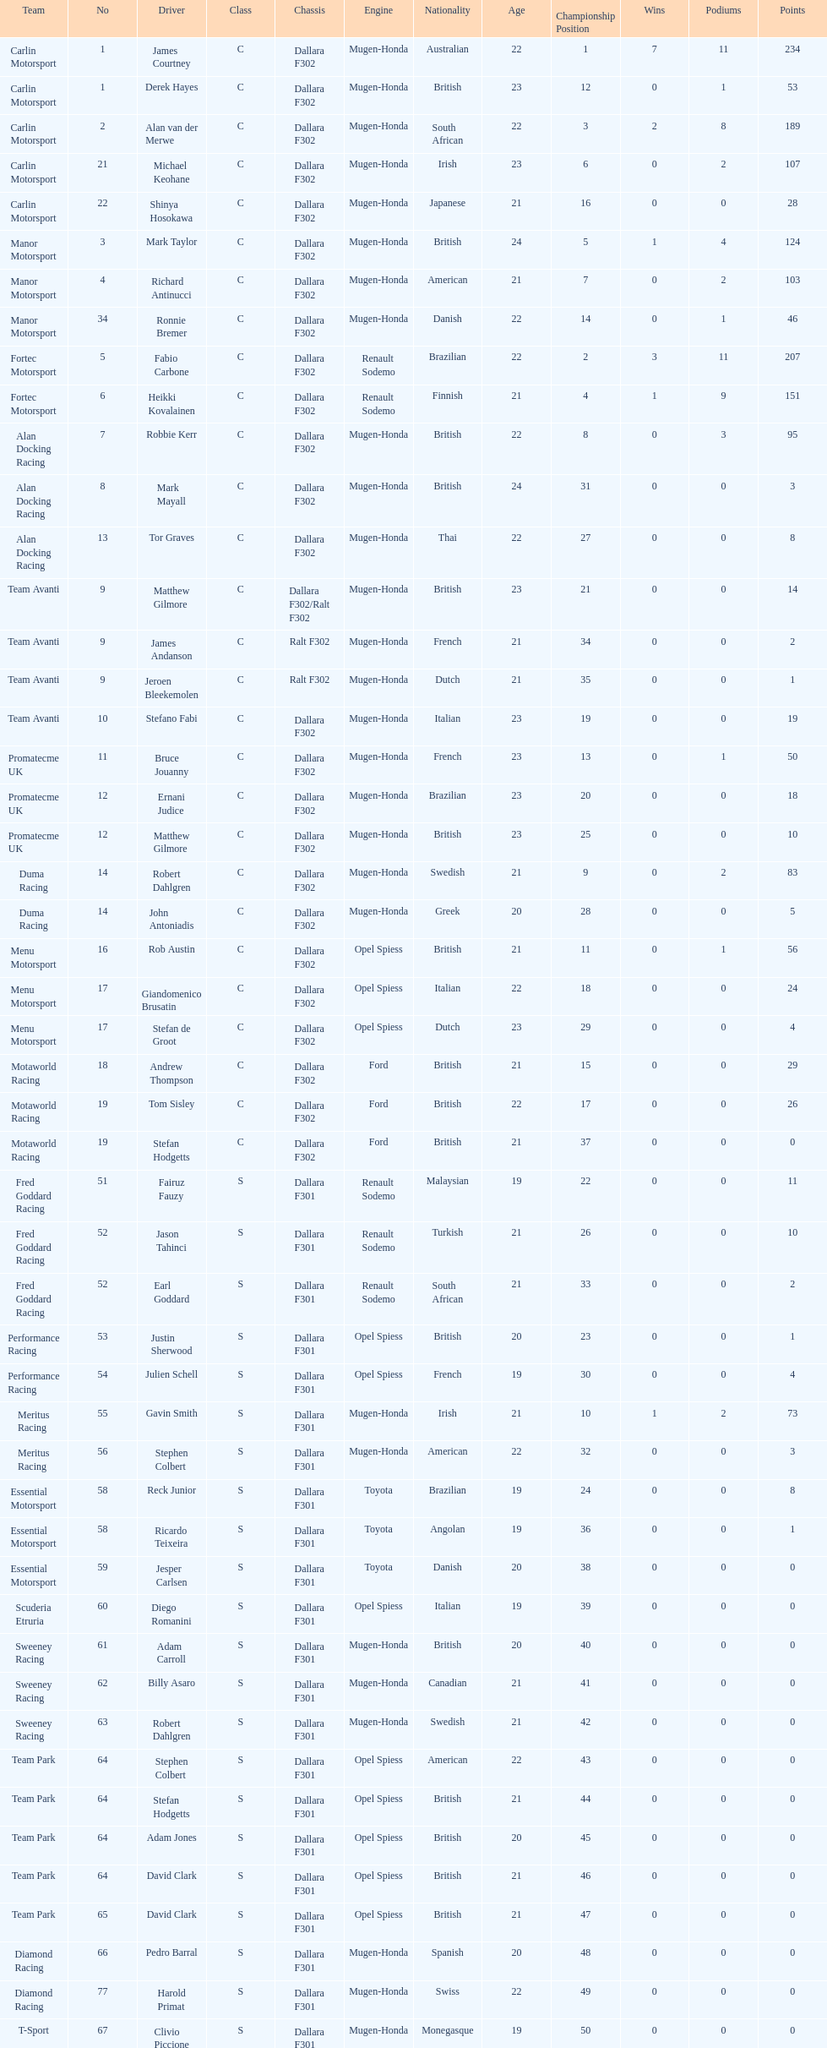Can you give me this table as a dict? {'header': ['Team', 'No', 'Driver', 'Class', 'Chassis', 'Engine', 'Nationality', 'Age', 'Championship Position', 'Wins', 'Podiums', 'Points'], 'rows': [['Carlin Motorsport', '1', 'James Courtney', 'C', 'Dallara F302', 'Mugen-Honda', 'Australian', '22', '1', '7', '11', '234'], ['Carlin Motorsport', '1', 'Derek Hayes', 'C', 'Dallara F302', 'Mugen-Honda', 'British', '23', '12', '0', '1', '53'], ['Carlin Motorsport', '2', 'Alan van der Merwe', 'C', 'Dallara F302', 'Mugen-Honda', 'South African', '22', '3', '2', '8', '189'], ['Carlin Motorsport', '21', 'Michael Keohane', 'C', 'Dallara F302', 'Mugen-Honda', 'Irish', '23', '6', '0', '2', '107'], ['Carlin Motorsport', '22', 'Shinya Hosokawa', 'C', 'Dallara F302', 'Mugen-Honda', 'Japanese', '21', '16', '0', '0', '28'], ['Manor Motorsport', '3', 'Mark Taylor', 'C', 'Dallara F302', 'Mugen-Honda', 'British', '24', '5', '1', '4', '124'], ['Manor Motorsport', '4', 'Richard Antinucci', 'C', 'Dallara F302', 'Mugen-Honda', 'American', '21', '7', '0', '2', '103'], ['Manor Motorsport', '34', 'Ronnie Bremer', 'C', 'Dallara F302', 'Mugen-Honda', 'Danish', '22', '14', '0', '1', '46'], ['Fortec Motorsport', '5', 'Fabio Carbone', 'C', 'Dallara F302', 'Renault Sodemo', 'Brazilian', '22', '2', '3', '11', '207'], ['Fortec Motorsport', '6', 'Heikki Kovalainen', 'C', 'Dallara F302', 'Renault Sodemo', 'Finnish', '21', '4', '1', '9', '151'], ['Alan Docking Racing', '7', 'Robbie Kerr', 'C', 'Dallara F302', 'Mugen-Honda', 'British', '22', '8', '0', '3', '95'], ['Alan Docking Racing', '8', 'Mark Mayall', 'C', 'Dallara F302', 'Mugen-Honda', 'British', '24', '31', '0', '0', '3'], ['Alan Docking Racing', '13', 'Tor Graves', 'C', 'Dallara F302', 'Mugen-Honda', 'Thai', '22', '27', '0', '0', '8'], ['Team Avanti', '9', 'Matthew Gilmore', 'C', 'Dallara F302/Ralt F302', 'Mugen-Honda', 'British', '23', '21', '0', '0', '14'], ['Team Avanti', '9', 'James Andanson', 'C', 'Ralt F302', 'Mugen-Honda', 'French', '21', '34', '0', '0', '2'], ['Team Avanti', '9', 'Jeroen Bleekemolen', 'C', 'Ralt F302', 'Mugen-Honda', 'Dutch', '21', '35', '0', '0', '1'], ['Team Avanti', '10', 'Stefano Fabi', 'C', 'Dallara F302', 'Mugen-Honda', 'Italian', '23', '19', '0', '0', '19'], ['Promatecme UK', '11', 'Bruce Jouanny', 'C', 'Dallara F302', 'Mugen-Honda', 'French', '23', '13', '0', '1', '50'], ['Promatecme UK', '12', 'Ernani Judice', 'C', 'Dallara F302', 'Mugen-Honda', 'Brazilian', '23', '20', '0', '0', '18'], ['Promatecme UK', '12', 'Matthew Gilmore', 'C', 'Dallara F302', 'Mugen-Honda', 'British', '23', '25', '0', '0', '10'], ['Duma Racing', '14', 'Robert Dahlgren', 'C', 'Dallara F302', 'Mugen-Honda', 'Swedish', '21', '9', '0', '2', '83'], ['Duma Racing', '14', 'John Antoniadis', 'C', 'Dallara F302', 'Mugen-Honda', 'Greek', '20', '28', '0', '0', '5'], ['Menu Motorsport', '16', 'Rob Austin', 'C', 'Dallara F302', 'Opel Spiess', 'British', '21', '11', '0', '1', '56'], ['Menu Motorsport', '17', 'Giandomenico Brusatin', 'C', 'Dallara F302', 'Opel Spiess', 'Italian', '22', '18', '0', '0', '24'], ['Menu Motorsport', '17', 'Stefan de Groot', 'C', 'Dallara F302', 'Opel Spiess', 'Dutch', '23', '29', '0', '0', '4'], ['Motaworld Racing', '18', 'Andrew Thompson', 'C', 'Dallara F302', 'Ford', 'British', '21', '15', '0', '0', '29'], ['Motaworld Racing', '19', 'Tom Sisley', 'C', 'Dallara F302', 'Ford', 'British', '22', '17', '0', '0', '26'], ['Motaworld Racing', '19', 'Stefan Hodgetts', 'C', 'Dallara F302', 'Ford', 'British', '21', '37', '0', '0', '0'], ['Fred Goddard Racing', '51', 'Fairuz Fauzy', 'S', 'Dallara F301', 'Renault Sodemo', 'Malaysian', '19', '22', '0', '0', '11'], ['Fred Goddard Racing', '52', 'Jason Tahinci', 'S', 'Dallara F301', 'Renault Sodemo', 'Turkish', '21', '26', '0', '0', '10'], ['Fred Goddard Racing', '52', 'Earl Goddard', 'S', 'Dallara F301', 'Renault Sodemo', 'South African', '21', '33', '0', '0', '2'], ['Performance Racing', '53', 'Justin Sherwood', 'S', 'Dallara F301', 'Opel Spiess', 'British', '20', '23', '0', '0', '1'], ['Performance Racing', '54', 'Julien Schell', 'S', 'Dallara F301', 'Opel Spiess', 'French', '19', '30', '0', '0', '4'], ['Meritus Racing', '55', 'Gavin Smith', 'S', 'Dallara F301', 'Mugen-Honda', 'Irish', '21', '10', '1', '2', '73'], ['Meritus Racing', '56', 'Stephen Colbert', 'S', 'Dallara F301', 'Mugen-Honda', 'American', '22', '32', '0', '0', '3'], ['Essential Motorsport', '58', 'Reck Junior', 'S', 'Dallara F301', 'Toyota', 'Brazilian', '19', '24', '0', '0', '8'], ['Essential Motorsport', '58', 'Ricardo Teixeira', 'S', 'Dallara F301', 'Toyota', 'Angolan', '19', '36', '0', '0', '1'], ['Essential Motorsport', '59', 'Jesper Carlsen', 'S', 'Dallara F301', 'Toyota', 'Danish', '20', '38', '0', '0', '0'], ['Scuderia Etruria', '60', 'Diego Romanini', 'S', 'Dallara F301', 'Opel Spiess', 'Italian', '19', '39', '0', '0', '0'], ['Sweeney Racing', '61', 'Adam Carroll', 'S', 'Dallara F301', 'Mugen-Honda', 'British', '20', '40', '0', '0', '0'], ['Sweeney Racing', '62', 'Billy Asaro', 'S', 'Dallara F301', 'Mugen-Honda', 'Canadian', '21', '41', '0', '0', '0'], ['Sweeney Racing', '63', 'Robert Dahlgren', 'S', 'Dallara F301', 'Mugen-Honda', 'Swedish', '21', '42', '0', '0', '0'], ['Team Park', '64', 'Stephen Colbert', 'S', 'Dallara F301', 'Opel Spiess', 'American', '22', '43', '0', '0', '0'], ['Team Park', '64', 'Stefan Hodgetts', 'S', 'Dallara F301', 'Opel Spiess', 'British', '21', '44', '0', '0', '0'], ['Team Park', '64', 'Adam Jones', 'S', 'Dallara F301', 'Opel Spiess', 'British', '20', '45', '0', '0', '0'], ['Team Park', '64', 'David Clark', 'S', 'Dallara F301', 'Opel Spiess', 'British', '21', '46', '0', '0', '0'], ['Team Park', '65', 'David Clark', 'S', 'Dallara F301', 'Opel Spiess', 'British', '21', '47', '0', '0', '0'], ['Diamond Racing', '66', 'Pedro Barral', 'S', 'Dallara F301', 'Mugen-Honda', 'Spanish', '20', '48', '0', '0', '0'], ['Diamond Racing', '77', 'Harold Primat', 'S', 'Dallara F301', 'Mugen-Honda', 'Swiss', '22', '49', '0', '0', '0'], ['T-Sport', '67', 'Clivio Piccione', 'S', 'Dallara F301', 'Mugen-Honda', 'Monegasque', '19', '50', '0', '0', '0'], ['T-Sport', '68', 'Karun Chandhok', 'S', 'Dallara F301', 'Mugen-Honda', 'Indian', '18', '51', '0', '0', '0'], ['Hill Speed Motorsport', '69', 'Luke Stevens', 'S', 'Dallara F301', 'Opel Spiess', 'British', '21', '52', '0', '0', '0']]} What is the number of teams that had drivers all from the same country? 4. 